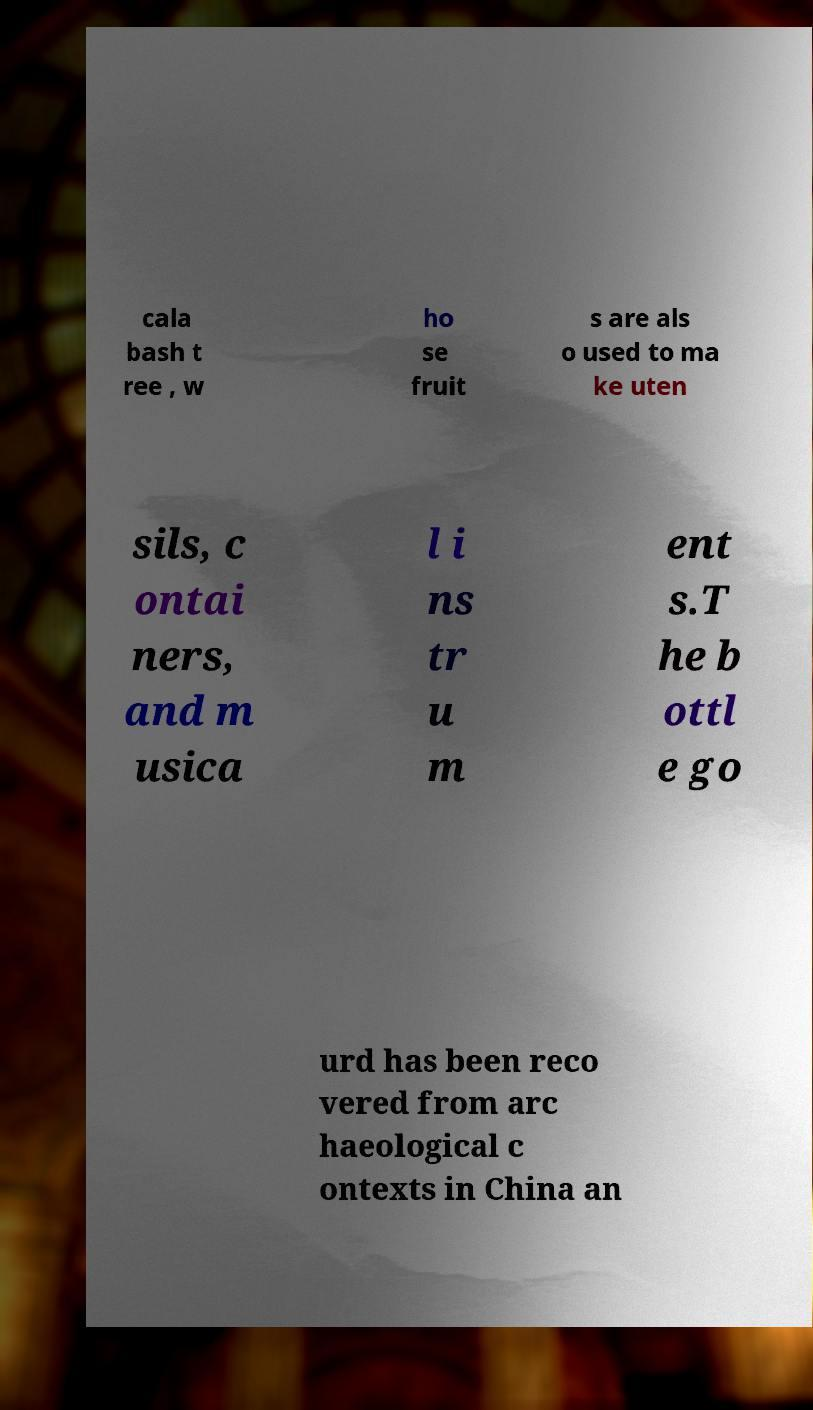For documentation purposes, I need the text within this image transcribed. Could you provide that? cala bash t ree , w ho se fruit s are als o used to ma ke uten sils, c ontai ners, and m usica l i ns tr u m ent s.T he b ottl e go urd has been reco vered from arc haeological c ontexts in China an 